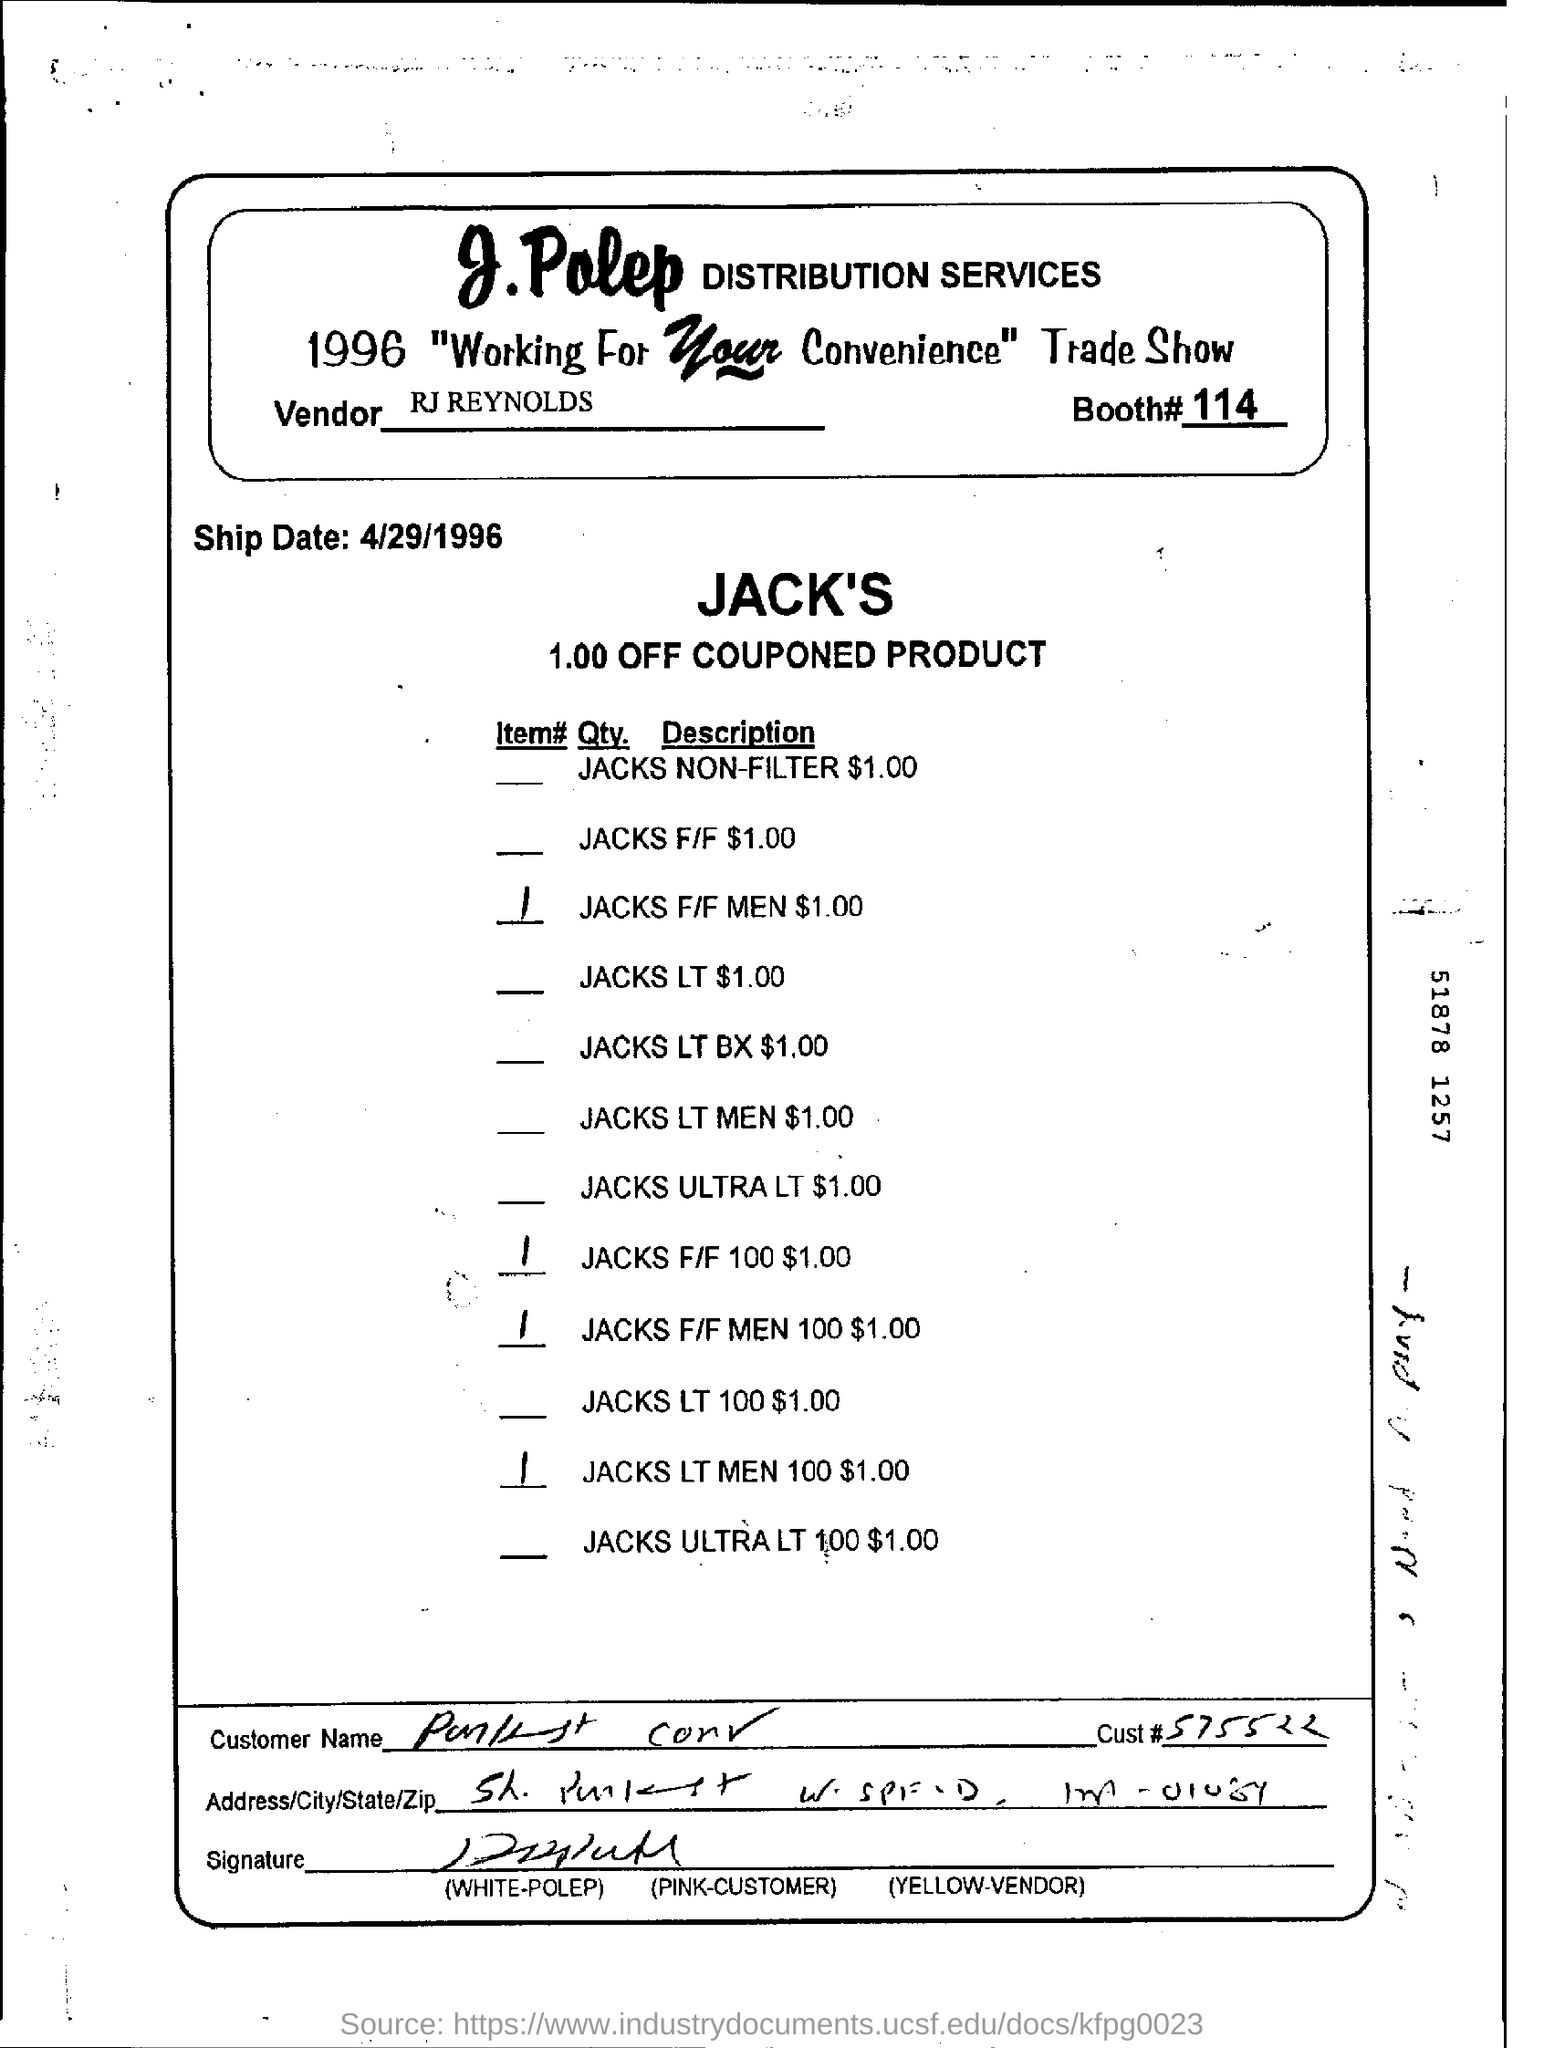What is the booth no. mentioned ?
Your response must be concise. 114. 